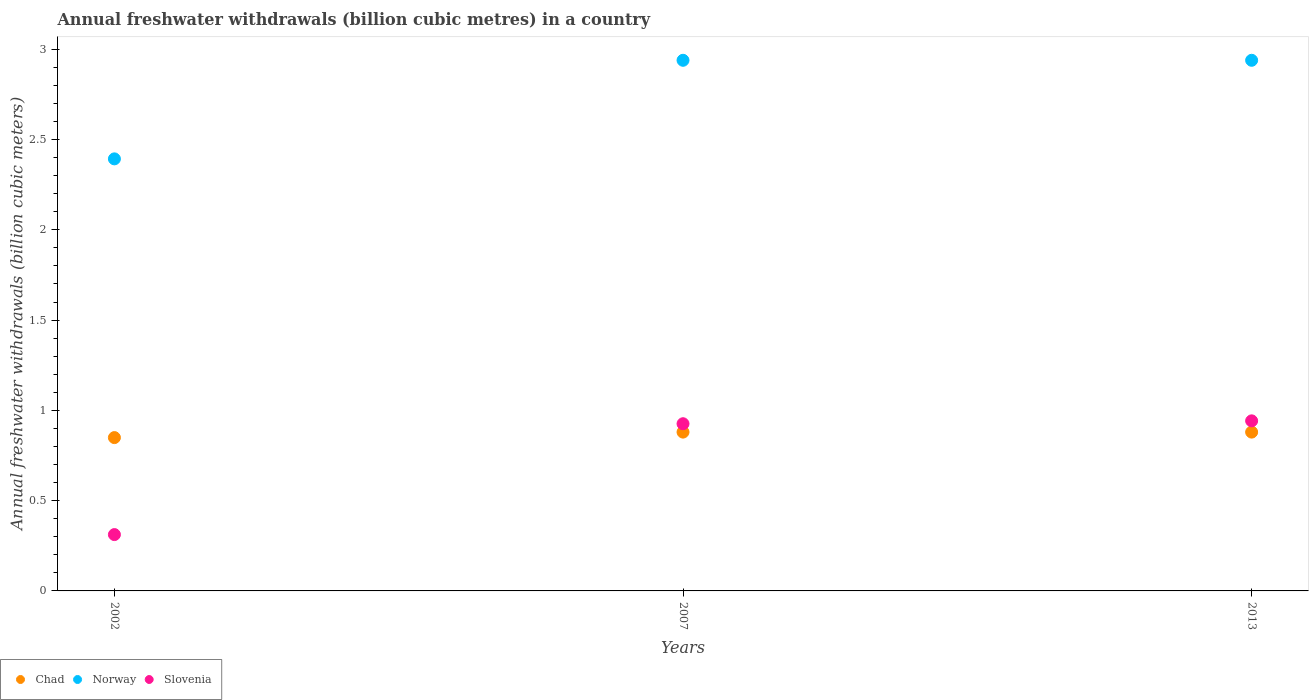Is the number of dotlines equal to the number of legend labels?
Offer a terse response. Yes. What is the annual freshwater withdrawals in Slovenia in 2013?
Provide a short and direct response. 0.94. Across all years, what is the maximum annual freshwater withdrawals in Slovenia?
Make the answer very short. 0.94. Across all years, what is the minimum annual freshwater withdrawals in Slovenia?
Keep it short and to the point. 0.31. In which year was the annual freshwater withdrawals in Norway maximum?
Your answer should be compact. 2007. In which year was the annual freshwater withdrawals in Chad minimum?
Your answer should be very brief. 2002. What is the total annual freshwater withdrawals in Norway in the graph?
Provide a short and direct response. 8.27. What is the difference between the annual freshwater withdrawals in Norway in 2002 and that in 2013?
Give a very brief answer. -0.55. What is the difference between the annual freshwater withdrawals in Slovenia in 2002 and the annual freshwater withdrawals in Norway in 2013?
Ensure brevity in your answer.  -2.63. What is the average annual freshwater withdrawals in Norway per year?
Provide a succinct answer. 2.76. In the year 2013, what is the difference between the annual freshwater withdrawals in Chad and annual freshwater withdrawals in Slovenia?
Give a very brief answer. -0.06. What is the ratio of the annual freshwater withdrawals in Norway in 2002 to that in 2013?
Keep it short and to the point. 0.81. Is the difference between the annual freshwater withdrawals in Chad in 2002 and 2007 greater than the difference between the annual freshwater withdrawals in Slovenia in 2002 and 2007?
Keep it short and to the point. Yes. What is the difference between the highest and the second highest annual freshwater withdrawals in Slovenia?
Give a very brief answer. 0.02. What is the difference between the highest and the lowest annual freshwater withdrawals in Chad?
Give a very brief answer. 0.03. Does the annual freshwater withdrawals in Chad monotonically increase over the years?
Offer a very short reply. No. Is the annual freshwater withdrawals in Norway strictly greater than the annual freshwater withdrawals in Slovenia over the years?
Keep it short and to the point. Yes. What is the difference between two consecutive major ticks on the Y-axis?
Give a very brief answer. 0.5. Does the graph contain any zero values?
Give a very brief answer. No. Does the graph contain grids?
Offer a terse response. No. How many legend labels are there?
Your response must be concise. 3. How are the legend labels stacked?
Provide a short and direct response. Horizontal. What is the title of the graph?
Your response must be concise. Annual freshwater withdrawals (billion cubic metres) in a country. Does "Egypt, Arab Rep." appear as one of the legend labels in the graph?
Offer a very short reply. No. What is the label or title of the Y-axis?
Ensure brevity in your answer.  Annual freshwater withdrawals (billion cubic meters). What is the Annual freshwater withdrawals (billion cubic meters) of Chad in 2002?
Ensure brevity in your answer.  0.85. What is the Annual freshwater withdrawals (billion cubic meters) in Norway in 2002?
Offer a terse response. 2.39. What is the Annual freshwater withdrawals (billion cubic meters) of Slovenia in 2002?
Give a very brief answer. 0.31. What is the Annual freshwater withdrawals (billion cubic meters) of Chad in 2007?
Your response must be concise. 0.88. What is the Annual freshwater withdrawals (billion cubic meters) in Norway in 2007?
Your answer should be very brief. 2.94. What is the Annual freshwater withdrawals (billion cubic meters) of Slovenia in 2007?
Make the answer very short. 0.93. What is the Annual freshwater withdrawals (billion cubic meters) of Chad in 2013?
Your answer should be compact. 0.88. What is the Annual freshwater withdrawals (billion cubic meters) in Norway in 2013?
Give a very brief answer. 2.94. What is the Annual freshwater withdrawals (billion cubic meters) in Slovenia in 2013?
Provide a succinct answer. 0.94. Across all years, what is the maximum Annual freshwater withdrawals (billion cubic meters) of Chad?
Keep it short and to the point. 0.88. Across all years, what is the maximum Annual freshwater withdrawals (billion cubic meters) in Norway?
Provide a short and direct response. 2.94. Across all years, what is the maximum Annual freshwater withdrawals (billion cubic meters) of Slovenia?
Your response must be concise. 0.94. Across all years, what is the minimum Annual freshwater withdrawals (billion cubic meters) in Chad?
Your answer should be very brief. 0.85. Across all years, what is the minimum Annual freshwater withdrawals (billion cubic meters) of Norway?
Ensure brevity in your answer.  2.39. Across all years, what is the minimum Annual freshwater withdrawals (billion cubic meters) of Slovenia?
Make the answer very short. 0.31. What is the total Annual freshwater withdrawals (billion cubic meters) of Chad in the graph?
Offer a terse response. 2.61. What is the total Annual freshwater withdrawals (billion cubic meters) in Norway in the graph?
Offer a very short reply. 8.27. What is the total Annual freshwater withdrawals (billion cubic meters) of Slovenia in the graph?
Your answer should be compact. 2.18. What is the difference between the Annual freshwater withdrawals (billion cubic meters) in Chad in 2002 and that in 2007?
Keep it short and to the point. -0.03. What is the difference between the Annual freshwater withdrawals (billion cubic meters) in Norway in 2002 and that in 2007?
Offer a very short reply. -0.55. What is the difference between the Annual freshwater withdrawals (billion cubic meters) in Slovenia in 2002 and that in 2007?
Provide a succinct answer. -0.61. What is the difference between the Annual freshwater withdrawals (billion cubic meters) in Chad in 2002 and that in 2013?
Make the answer very short. -0.03. What is the difference between the Annual freshwater withdrawals (billion cubic meters) of Norway in 2002 and that in 2013?
Your response must be concise. -0.55. What is the difference between the Annual freshwater withdrawals (billion cubic meters) of Slovenia in 2002 and that in 2013?
Your answer should be compact. -0.63. What is the difference between the Annual freshwater withdrawals (billion cubic meters) of Norway in 2007 and that in 2013?
Offer a very short reply. 0. What is the difference between the Annual freshwater withdrawals (billion cubic meters) of Slovenia in 2007 and that in 2013?
Keep it short and to the point. -0.02. What is the difference between the Annual freshwater withdrawals (billion cubic meters) in Chad in 2002 and the Annual freshwater withdrawals (billion cubic meters) in Norway in 2007?
Offer a terse response. -2.09. What is the difference between the Annual freshwater withdrawals (billion cubic meters) of Chad in 2002 and the Annual freshwater withdrawals (billion cubic meters) of Slovenia in 2007?
Ensure brevity in your answer.  -0.08. What is the difference between the Annual freshwater withdrawals (billion cubic meters) of Norway in 2002 and the Annual freshwater withdrawals (billion cubic meters) of Slovenia in 2007?
Keep it short and to the point. 1.47. What is the difference between the Annual freshwater withdrawals (billion cubic meters) in Chad in 2002 and the Annual freshwater withdrawals (billion cubic meters) in Norway in 2013?
Offer a very short reply. -2.09. What is the difference between the Annual freshwater withdrawals (billion cubic meters) in Chad in 2002 and the Annual freshwater withdrawals (billion cubic meters) in Slovenia in 2013?
Offer a very short reply. -0.09. What is the difference between the Annual freshwater withdrawals (billion cubic meters) of Norway in 2002 and the Annual freshwater withdrawals (billion cubic meters) of Slovenia in 2013?
Your answer should be compact. 1.45. What is the difference between the Annual freshwater withdrawals (billion cubic meters) in Chad in 2007 and the Annual freshwater withdrawals (billion cubic meters) in Norway in 2013?
Provide a succinct answer. -2.06. What is the difference between the Annual freshwater withdrawals (billion cubic meters) of Chad in 2007 and the Annual freshwater withdrawals (billion cubic meters) of Slovenia in 2013?
Your answer should be compact. -0.06. What is the difference between the Annual freshwater withdrawals (billion cubic meters) in Norway in 2007 and the Annual freshwater withdrawals (billion cubic meters) in Slovenia in 2013?
Your response must be concise. 2. What is the average Annual freshwater withdrawals (billion cubic meters) of Chad per year?
Offer a very short reply. 0.87. What is the average Annual freshwater withdrawals (billion cubic meters) in Norway per year?
Keep it short and to the point. 2.76. What is the average Annual freshwater withdrawals (billion cubic meters) of Slovenia per year?
Your answer should be very brief. 0.73. In the year 2002, what is the difference between the Annual freshwater withdrawals (billion cubic meters) in Chad and Annual freshwater withdrawals (billion cubic meters) in Norway?
Make the answer very short. -1.54. In the year 2002, what is the difference between the Annual freshwater withdrawals (billion cubic meters) in Chad and Annual freshwater withdrawals (billion cubic meters) in Slovenia?
Your response must be concise. 0.54. In the year 2002, what is the difference between the Annual freshwater withdrawals (billion cubic meters) in Norway and Annual freshwater withdrawals (billion cubic meters) in Slovenia?
Your answer should be very brief. 2.08. In the year 2007, what is the difference between the Annual freshwater withdrawals (billion cubic meters) in Chad and Annual freshwater withdrawals (billion cubic meters) in Norway?
Offer a very short reply. -2.06. In the year 2007, what is the difference between the Annual freshwater withdrawals (billion cubic meters) of Chad and Annual freshwater withdrawals (billion cubic meters) of Slovenia?
Offer a very short reply. -0.05. In the year 2007, what is the difference between the Annual freshwater withdrawals (billion cubic meters) of Norway and Annual freshwater withdrawals (billion cubic meters) of Slovenia?
Offer a terse response. 2.01. In the year 2013, what is the difference between the Annual freshwater withdrawals (billion cubic meters) of Chad and Annual freshwater withdrawals (billion cubic meters) of Norway?
Your response must be concise. -2.06. In the year 2013, what is the difference between the Annual freshwater withdrawals (billion cubic meters) of Chad and Annual freshwater withdrawals (billion cubic meters) of Slovenia?
Your answer should be very brief. -0.06. In the year 2013, what is the difference between the Annual freshwater withdrawals (billion cubic meters) in Norway and Annual freshwater withdrawals (billion cubic meters) in Slovenia?
Keep it short and to the point. 2. What is the ratio of the Annual freshwater withdrawals (billion cubic meters) of Chad in 2002 to that in 2007?
Your answer should be compact. 0.97. What is the ratio of the Annual freshwater withdrawals (billion cubic meters) in Norway in 2002 to that in 2007?
Your answer should be compact. 0.81. What is the ratio of the Annual freshwater withdrawals (billion cubic meters) of Slovenia in 2002 to that in 2007?
Offer a very short reply. 0.34. What is the ratio of the Annual freshwater withdrawals (billion cubic meters) of Chad in 2002 to that in 2013?
Give a very brief answer. 0.97. What is the ratio of the Annual freshwater withdrawals (billion cubic meters) in Norway in 2002 to that in 2013?
Make the answer very short. 0.81. What is the ratio of the Annual freshwater withdrawals (billion cubic meters) of Slovenia in 2002 to that in 2013?
Keep it short and to the point. 0.33. What is the ratio of the Annual freshwater withdrawals (billion cubic meters) of Norway in 2007 to that in 2013?
Keep it short and to the point. 1. What is the ratio of the Annual freshwater withdrawals (billion cubic meters) in Slovenia in 2007 to that in 2013?
Your answer should be compact. 0.98. What is the difference between the highest and the second highest Annual freshwater withdrawals (billion cubic meters) of Chad?
Offer a very short reply. 0. What is the difference between the highest and the second highest Annual freshwater withdrawals (billion cubic meters) in Norway?
Make the answer very short. 0. What is the difference between the highest and the second highest Annual freshwater withdrawals (billion cubic meters) of Slovenia?
Your response must be concise. 0.02. What is the difference between the highest and the lowest Annual freshwater withdrawals (billion cubic meters) of Chad?
Keep it short and to the point. 0.03. What is the difference between the highest and the lowest Annual freshwater withdrawals (billion cubic meters) of Norway?
Provide a succinct answer. 0.55. What is the difference between the highest and the lowest Annual freshwater withdrawals (billion cubic meters) in Slovenia?
Provide a succinct answer. 0.63. 